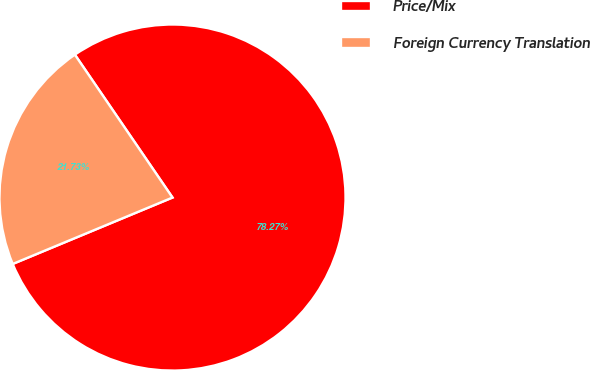Convert chart to OTSL. <chart><loc_0><loc_0><loc_500><loc_500><pie_chart><fcel>Price/Mix<fcel>Foreign Currency Translation<nl><fcel>78.27%<fcel>21.73%<nl></chart> 